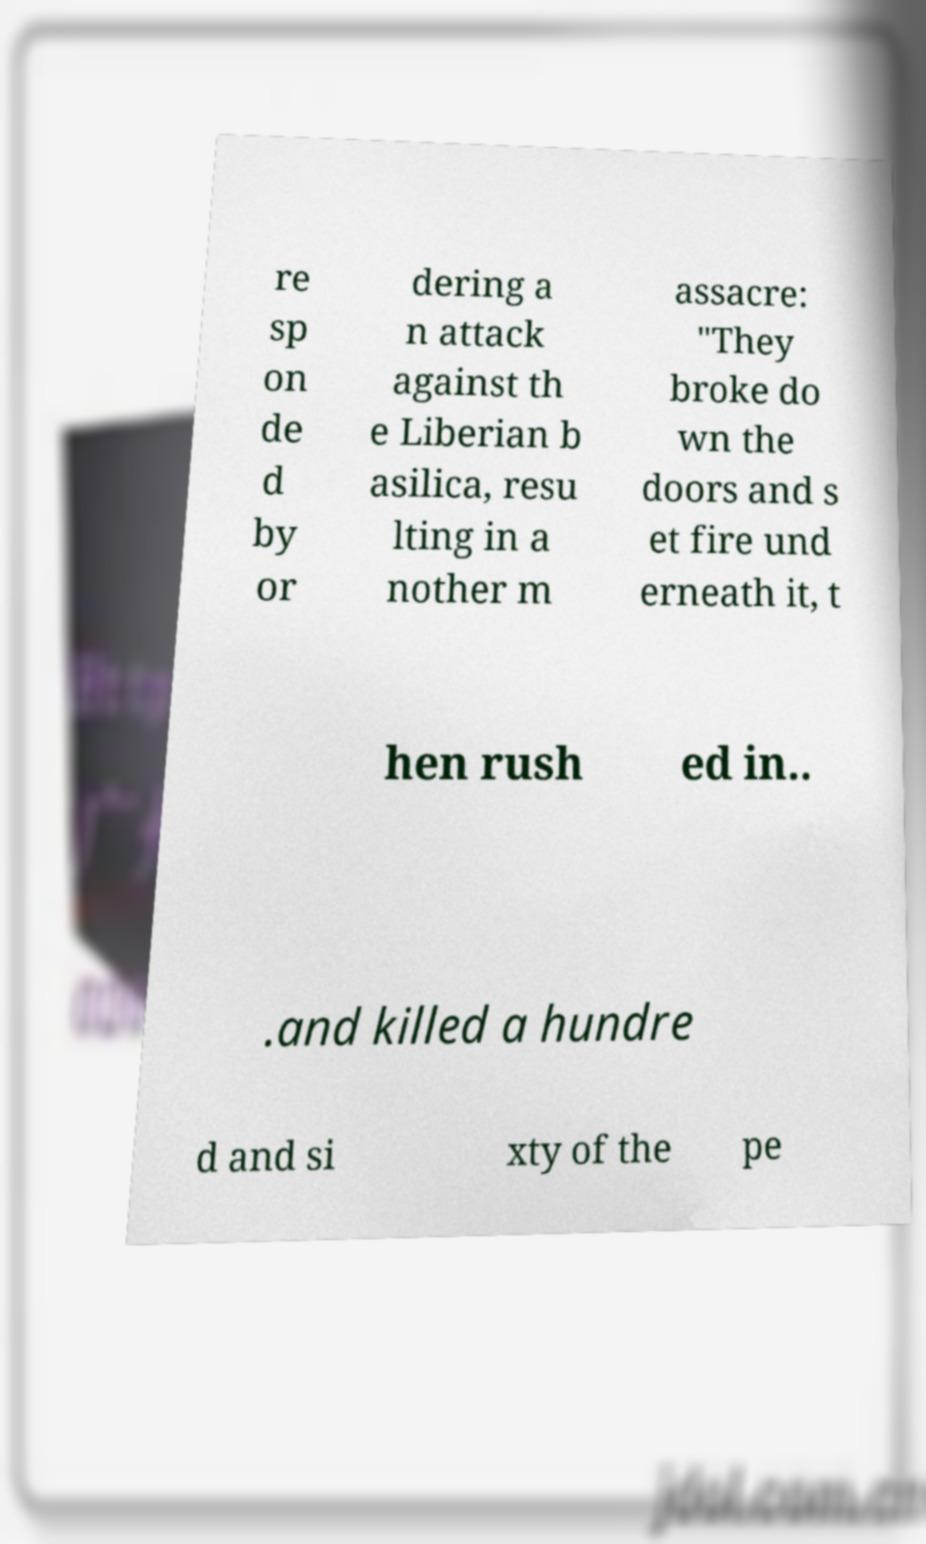For documentation purposes, I need the text within this image transcribed. Could you provide that? re sp on de d by or dering a n attack against th e Liberian b asilica, resu lting in a nother m assacre: "They broke do wn the doors and s et fire und erneath it, t hen rush ed in.. .and killed a hundre d and si xty of the pe 